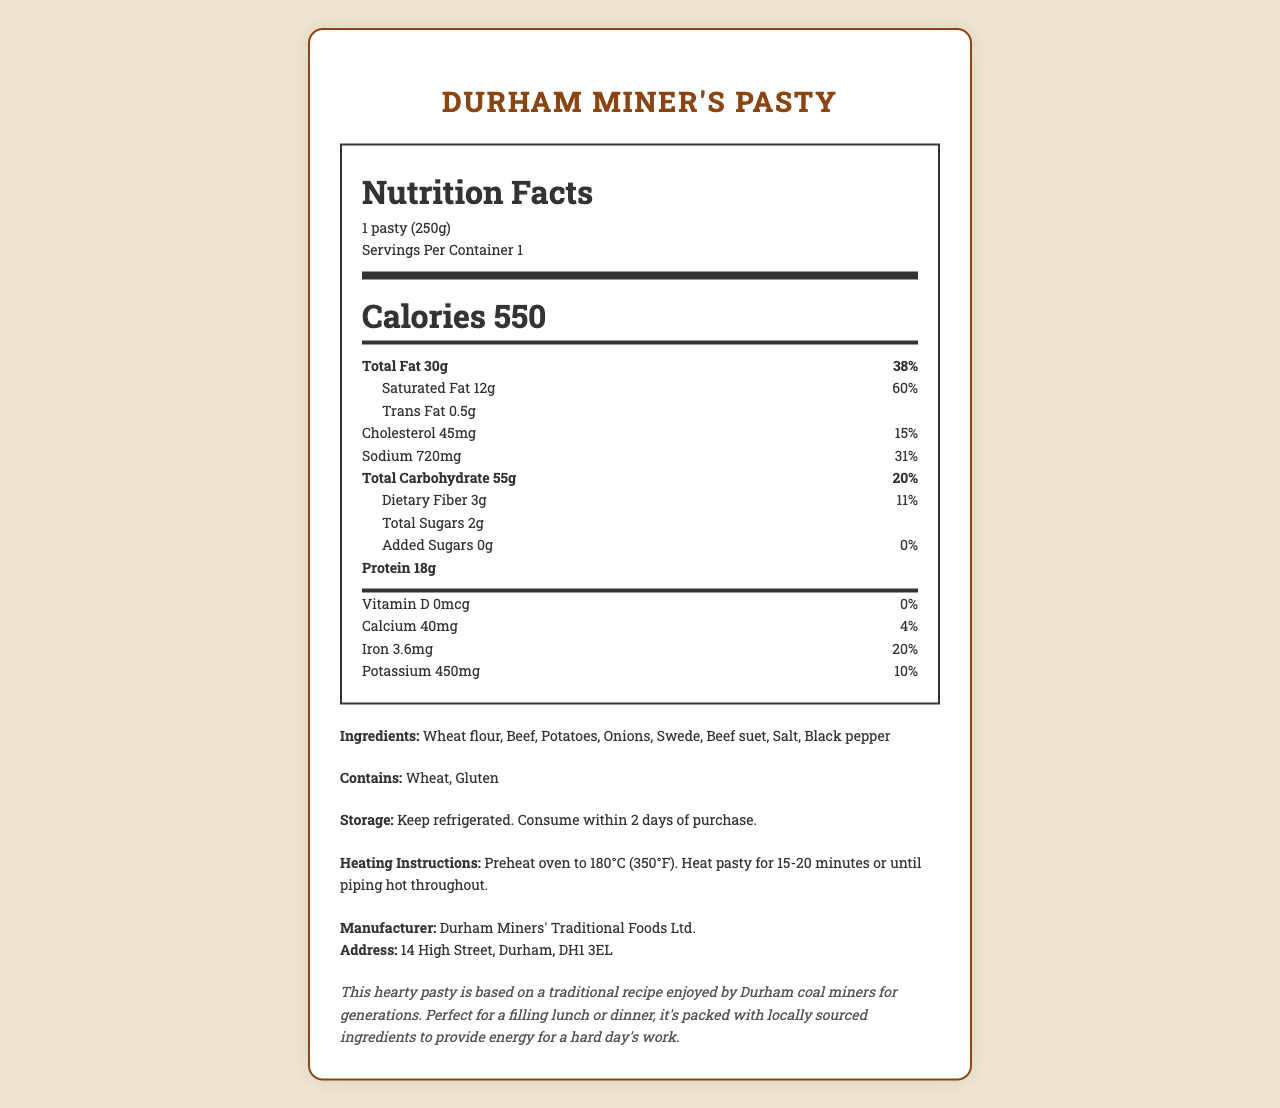what is the total calorie count for one serving? The label states that there are 550 calories per serving, and one serving size is one pasty (250g).
Answer: 550 calories how much saturated fat does the pasty contain? The label lists saturated fat content as 12 grams.
Answer: 12g what is the daily value percentage for sodium in the pasty? The label shows that the sodium daily value percentage is 31%.
Answer: 31% name the main ingredients of the Durham Miner's Pasty. The ingredients listed on the label are wheat flour, beef, potatoes, onions, swede, beef suet, salt, and black pepper.
Answer: Wheat flour, Beef, Potatoes, Onions, Swede, Beef suet, Salt, Black pepper how much protein is in one serving of the pasty? The nutrition label indicates that one serving contains 18 grams of protein.
Answer: 18g how many grams of dietary fiber are in the pasty? A. 1g B. 2g C. 3g D. 4g The label specifies that the pasty contains 3 grams of dietary fiber.
Answer: C. 3g out of the following, which nutrient's daily value percentage is the highest? A. Iron B. Sodium C. Total Fat D. Saturated Fat Saturated fat has the highest daily value percentage at 60%, followed by Total Fat (38%), Sodium (31%), and Iron (20%).
Answer: D. Saturated Fat does the pasty contain any added sugars? The label indicates that the pasty contains 0 grams of added sugars.
Answer: No are there any allergens in the pasty? The allergens listed are wheat and gluten.
Answer: Yes summarize the main purpose of this document. This nutrition facts label gives a comprehensive breakdown of the pasty's contents and relevant health information, along with preparation and storage guidelines.
Answer: The document provides detailed nutrition information for a Durham Miner's Pasty, including calories, nutrients, ingredients, allergens, storage instructions, heating instructions, manufacturer details, and additional historical context. how much potassium is in the pasty? The label states that the pasty contains 450 milligrams of potassium.
Answer: 450mg what company manufactures the Durham Miner's Pasty? The manufacturer is listed as Durham Miners' Traditional Foods Ltd.
Answer: Durham Miners' Traditional Foods Ltd. what is the daily value percentage for calcium in the pasty? The label shows that the daily value percentage for calcium is 4%.
Answer: 4% is there any vitamin D in the pasty? The label indicates that the pasty contains 0 micrograms of vitamin D, which corresponds to 0% of the daily value.
Answer: No what is the storage instruction for the pasty? The storage instruction provided on the label is to keep the pasty refrigerated and consume it within 2 days of purchase.
Answer: Keep refrigerated. Consume within 2 days of purchase. what kind of beef is used in the pasty? The label does not specify the type of beef used in the pasty; it only lists beef as an ingredient.
Answer: I don't know 